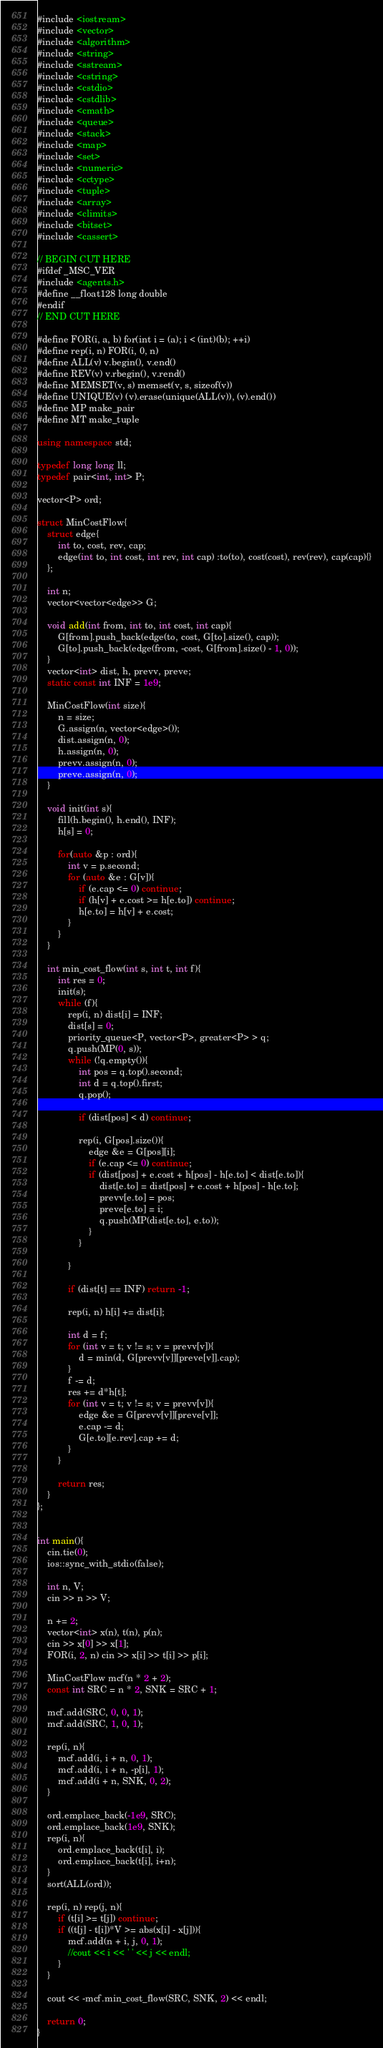Convert code to text. <code><loc_0><loc_0><loc_500><loc_500><_C++_>#include <iostream>
#include <vector>
#include <algorithm>
#include <string>
#include <sstream>
#include <cstring>
#include <cstdio>
#include <cstdlib>
#include <cmath>
#include <queue>
#include <stack>
#include <map>
#include <set>
#include <numeric>
#include <cctype>
#include <tuple>
#include <array>
#include <climits>
#include <bitset>
#include <cassert>

// BEGIN CUT HERE
#ifdef _MSC_VER
#include <agents.h>
#define __float128 long double
#endif
// END CUT HERE 

#define FOR(i, a, b) for(int i = (a); i < (int)(b); ++i)
#define rep(i, n) FOR(i, 0, n)
#define ALL(v) v.begin(), v.end()
#define REV(v) v.rbegin(), v.rend()
#define MEMSET(v, s) memset(v, s, sizeof(v))
#define UNIQUE(v) (v).erase(unique(ALL(v)), (v).end())
#define MP make_pair
#define MT make_tuple

using namespace std;

typedef long long ll;
typedef pair<int, int> P;

vector<P> ord;

struct MinCostFlow{
	struct edge{
		int to, cost, rev, cap;
		edge(int to, int cost, int rev, int cap) :to(to), cost(cost), rev(rev), cap(cap){}
	};

	int n;
	vector<vector<edge>> G;

	void add(int from, int to, int cost, int cap){
		G[from].push_back(edge(to, cost, G[to].size(), cap));
		G[to].push_back(edge(from, -cost, G[from].size() - 1, 0));
	}
	vector<int> dist, h, prevv, preve;
	static const int INF = 1e9;

	MinCostFlow(int size){
		n = size;
		G.assign(n, vector<edge>());
		dist.assign(n, 0);
		h.assign(n, 0);
		prevv.assign(n, 0);
		preve.assign(n, 0);
	}

	void init(int s){
		fill(h.begin(), h.end(), INF);
		h[s] = 0;

		for(auto &p : ord){
			int v = p.second;
			for (auto &e : G[v]){
				if (e.cap <= 0) continue;
				if (h[v] + e.cost >= h[e.to]) continue;
				h[e.to] = h[v] + e.cost;
			}
		}
	}

	int min_cost_flow(int s, int t, int f){
		int res = 0;
		init(s);
		while (f){
			rep(i, n) dist[i] = INF;
			dist[s] = 0;
			priority_queue<P, vector<P>, greater<P> > q;
			q.push(MP(0, s));
			while (!q.empty()){
				int pos = q.top().second;
				int d = q.top().first;
				q.pop();

				if (dist[pos] < d) continue;

				rep(i, G[pos].size()){
					edge &e = G[pos][i];
					if (e.cap <= 0) continue;
					if (dist[pos] + e.cost + h[pos] - h[e.to] < dist[e.to]){
						dist[e.to] = dist[pos] + e.cost + h[pos] - h[e.to];
						prevv[e.to] = pos;
						preve[e.to] = i;
						q.push(MP(dist[e.to], e.to));
					}
				}

			}

			if (dist[t] == INF) return -1;

			rep(i, n) h[i] += dist[i];

			int d = f;
			for (int v = t; v != s; v = prevv[v]){
				d = min(d, G[prevv[v]][preve[v]].cap);
			}
			f -= d;
			res += d*h[t];
			for (int v = t; v != s; v = prevv[v]){
				edge &e = G[prevv[v]][preve[v]];
				e.cap -= d;
				G[e.to][e.rev].cap += d;
			}
		}

		return res;
	}
};


int main(){
	cin.tie(0);
	ios::sync_with_stdio(false);

	int n, V;
	cin >> n >> V;

	n += 2;
	vector<int> x(n), t(n), p(n);
	cin >> x[0] >> x[1];
	FOR(i, 2, n) cin >> x[i] >> t[i] >> p[i];

	MinCostFlow mcf(n * 2 + 2);
	const int SRC = n * 2, SNK = SRC + 1;

	mcf.add(SRC, 0, 0, 1);
	mcf.add(SRC, 1, 0, 1);

	rep(i, n){
		mcf.add(i, i + n, 0, 1);
		mcf.add(i, i + n, -p[i], 1);
		mcf.add(i + n, SNK, 0, 2);
	}

	ord.emplace_back(-1e9, SRC);
	ord.emplace_back(1e9, SNK);
	rep(i, n){
		ord.emplace_back(t[i], i);
		ord.emplace_back(t[i], i+n);
	}
	sort(ALL(ord));

	rep(i, n) rep(j, n){
		if (t[i] >= t[j]) continue;
		if ((t[j] - t[i])*V >= abs(x[i] - x[j])){
			mcf.add(n + i, j, 0, 1);
			//cout << i << ' ' << j << endl;
		}
	}

	cout << -mcf.min_cost_flow(SRC, SNK, 2) << endl;

	return 0;
}</code> 